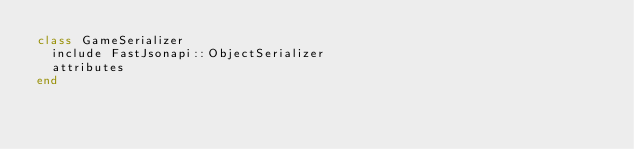Convert code to text. <code><loc_0><loc_0><loc_500><loc_500><_Ruby_>class GameSerializer
  include FastJsonapi::ObjectSerializer
  attributes 
end
</code> 